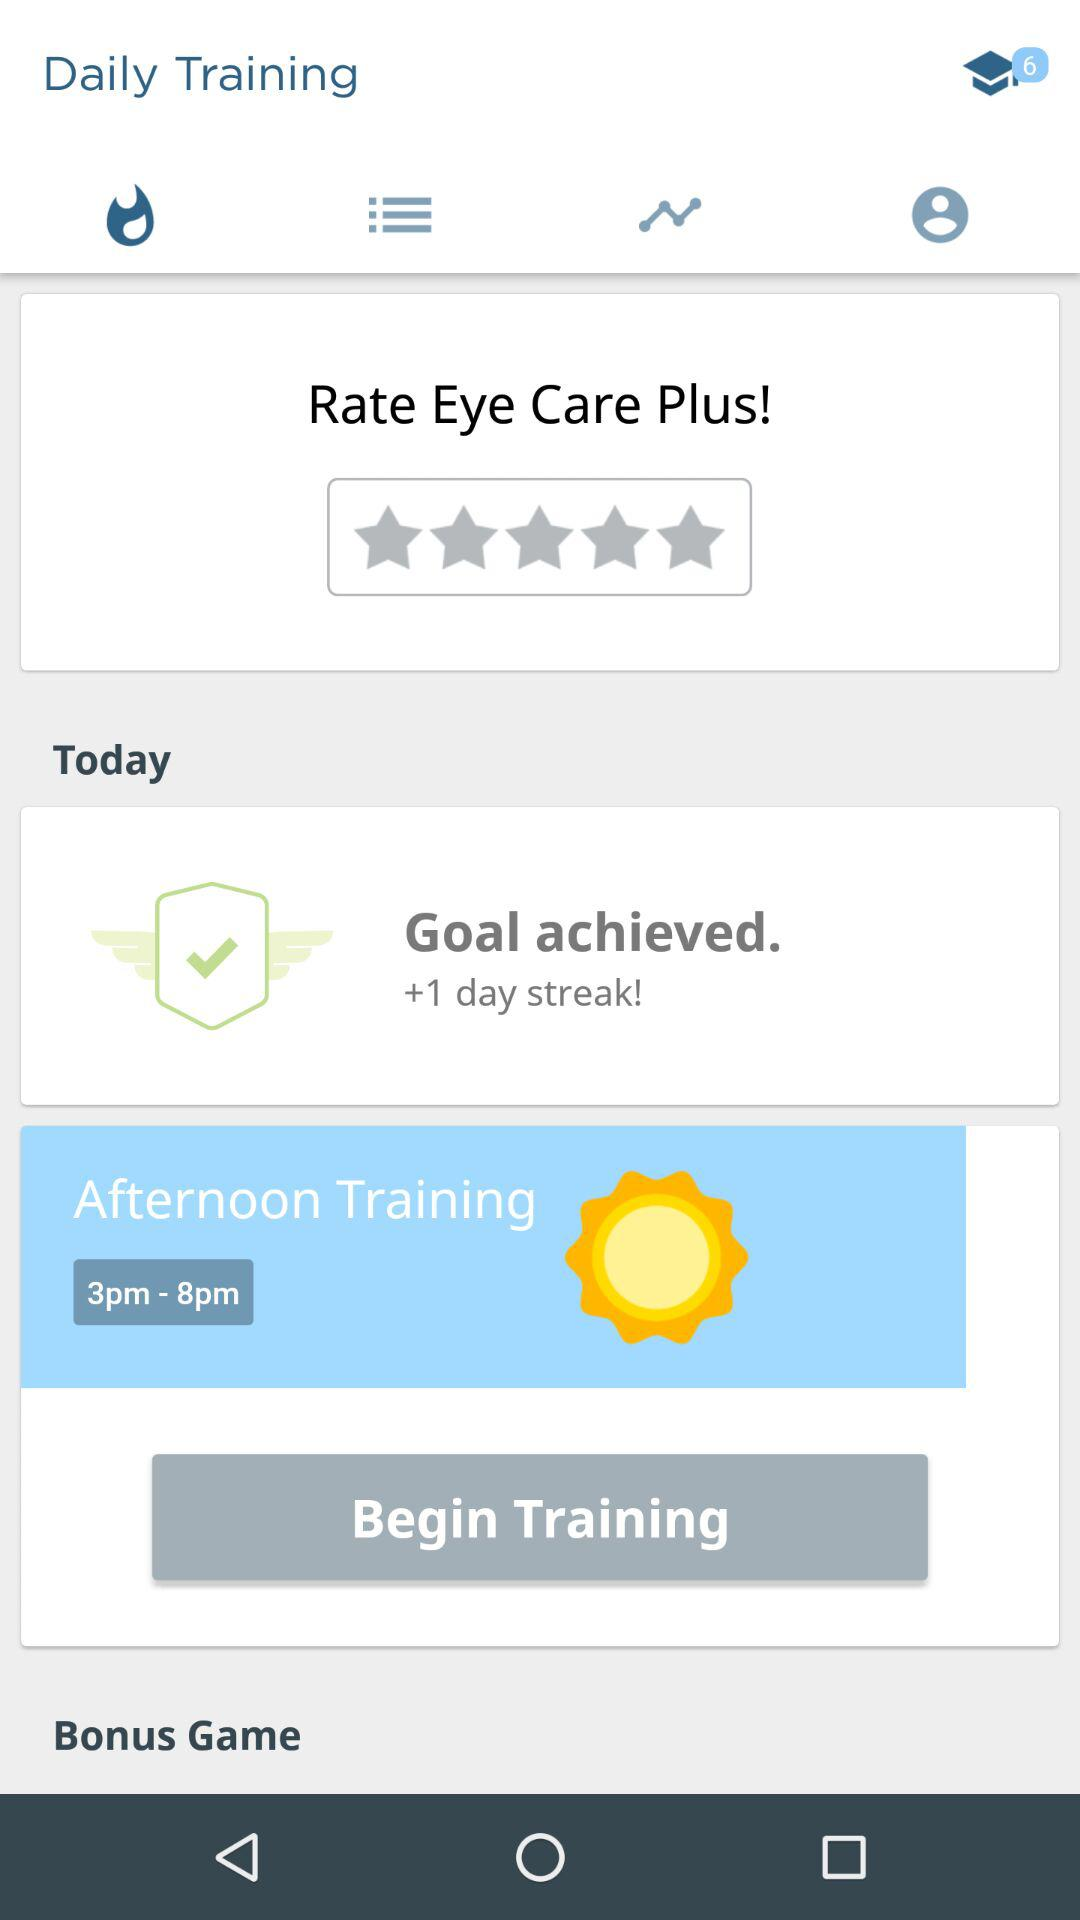How many hours long is the Afternoon Training session?
Answer the question using a single word or phrase. 5 